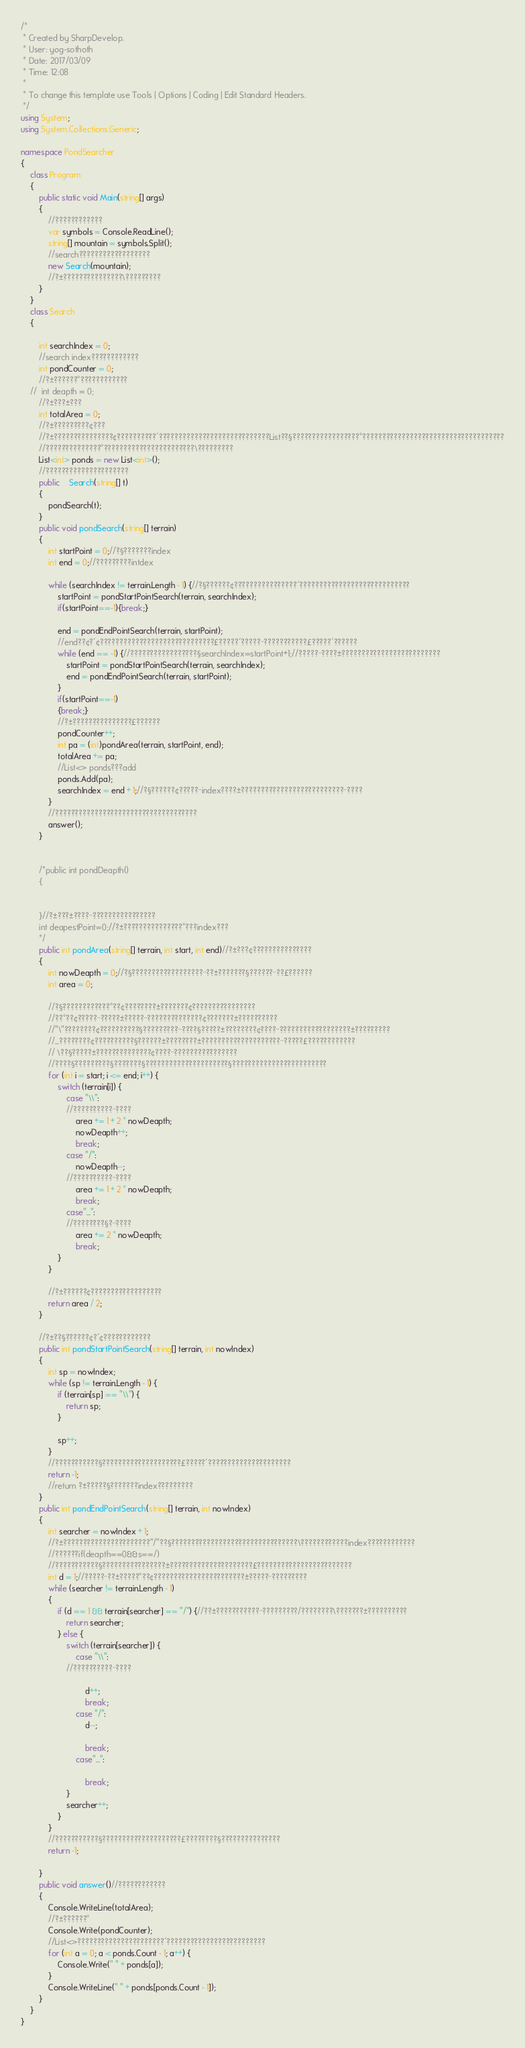Convert code to text. <code><loc_0><loc_0><loc_500><loc_500><_C#_>/*
 * Created by SharpDevelop.
 * User: yog-sothoth
 * Date: 2017/03/09
 * Time: 12:08
 * 
 * To change this template use Tools | Options | Coding | Edit Standard Headers.
 */
using System;
using System.Collections.Generic;

namespace PondSearcher
{
	class Program
	{
		public static void Main(string[] args)
		{
			//????????????
			var symbols = Console.ReadLine();
			string[] mountain = symbols.Split();
			//search??????????????????
			new Search(mountain);
			//?±???????????????\?????????
		}
	}
	class Search
	{

		int searchIndex = 0;
		//search index????????????
		int pondCounter = 0;
		//?±??????°????????????
	//	int deapth = 0;
		//?±???±???
		int totalArea = 0;
		//?±?????????¢???
		//?±???????????????¢??????????´????????????????????????????List??§?????????????????°????????????????????????????????????
		//??????????????°???????????????????????\?????????
		List<int> ponds = new List<int>();
		//?????????????????????
		public	Search(string[] t)
		{
			pondSearch(t);
		}
		public void pondSearch(string[] terrain)
		{
			int startPoint = 0;//?§???????index
			int end = 0;//?????????intdex	  
		 
			while (searchIndex != terrain.Length - 1) {//?§??????¢????????????????´????????????????????????????
				startPoint = pondStartPointSearch(terrain, searchIndex);
				if(startPoint==-1){break;}
					
				end = pondEndPointSearch(terrain, startPoint);
				//end??¢?´¢?????????????????????????????£?????´?????¨???????????£?????´??????
				while (end == -1) {//?????????????????§searchIndex=startPoint+1;//?????¨????±?????????????????????????
					startPoint = pondStartPointSearch(terrain, searchIndex);
					end = pondEndPointSearch(terrain, startPoint);	
				}
				if(startPoint==-1)
				{break;}
				//?±???????????????£??????
				pondCounter++;
				int pa = (int)pondArea(terrain, startPoint, end);
				totalArea += pa;
				//List<> ponds???add
				ponds.Add(pa);
				searchIndex = end + 1;//?§??????¢?????¨index????±??????????????????????????¨????
			}
			//????????????????????????????????????
			answer();
		}
		
				
		/*public int pondDeapth()
		{
		
		
		}//?±???±????¨????????????????
		int deapestPoint=0;//?±???????????????°???index???
		*/
		public int pondArea(string[] terrain, int start, int end)//?±???¢???????????????
		{
			int nowDeapth = 0;//?§??????????????????¨??±???????§??????¨??£??????
			int area = 0;
				
			//?§????????????°??¢????????±???????¢????????????????
			//??°??¢?????¨?????±?????¨??????????????¢???????±??????????
			//"\"????????¢??????????§?????????¨????§?????±????????¢????¨??????????????????±?????????
			//_????????¢??????????§??????±????????±????????????????????¨?????£????????????
			// \??§?????±??????????????¢????¨????????????????
			//????§?????????§???????§?????????????????????§????????????????????????
			for (int i = start; i <= end; i++) {
				switch (terrain[i]) {
					case "\\":
					//??????????¨????
						area += 1 + 2 * nowDeapth;
						nowDeapth++;
						break;
					case "/":
						nowDeapth--;
					//??????????¨????
						area += 1 + 2 * nowDeapth;
						break;
					case"_":
					//????????§?¨????
						area += 2 * nowDeapth;
						break;						
				}
			}
		
			//?±??????¢??????????????????
			return area / 2;
		}
	
		//?±??§??????¢?´¢????????????
		public int pondStartPointSearch(string[] terrain, int nowIndex)
		{
			int sp = nowIndex;
			while (sp != terrain.Length - 1) {
				if (terrain[sp] == "\\") {
					return sp;
				}
								
				sp++;
			}
			//???????????§????????????????????£?????´?????????????????????
			return -1;
			//return ?±?????§???????index?????????
		}
		public int pondEndPointSearch(string[] terrain, int nowIndex)
		{
			int searcher = nowIndex + 1;			
			//?±??????????????????????"/"??§????????????????????????????????\????????????index????????????
			//??????if(deapth==0&&s==/)
			//???????????§????????????????±?????????????????????£????????????????????????
			int d = 1;//?????¨??±?????°??¢???????????????????????±?????¨?????????
			while (searcher != terrain.Length - 1) 
			{
				if (d == 1 && terrain[searcher] == "/") {//??±???????????¨?????????/????????\???????±??????????
					return searcher;
				} else {
					switch (terrain[searcher]) {
						case "\\":
					//??????????¨????
					
							d++;
							break;
						case "/":
							d--;
					
							break;
						case"_":
					
							break;						
					}
					searcher++;
				}
			}
			//???????????§????????????????????£????????§???????????????
			return -1;
		
		}
		public void answer()//????????????
		{
			Console.WriteLine(totalArea);
			//?±??????°
			Console.Write(pondCounter);
			//List<>??????????????????????´?????????????????????????
			for (int a = 0; a < ponds.Count - 1; a++) {
				Console.Write(" " + ponds[a]);
			}
			Console.WriteLine(" " + ponds[ponds.Count - 1]);
		}
	}
}</code> 